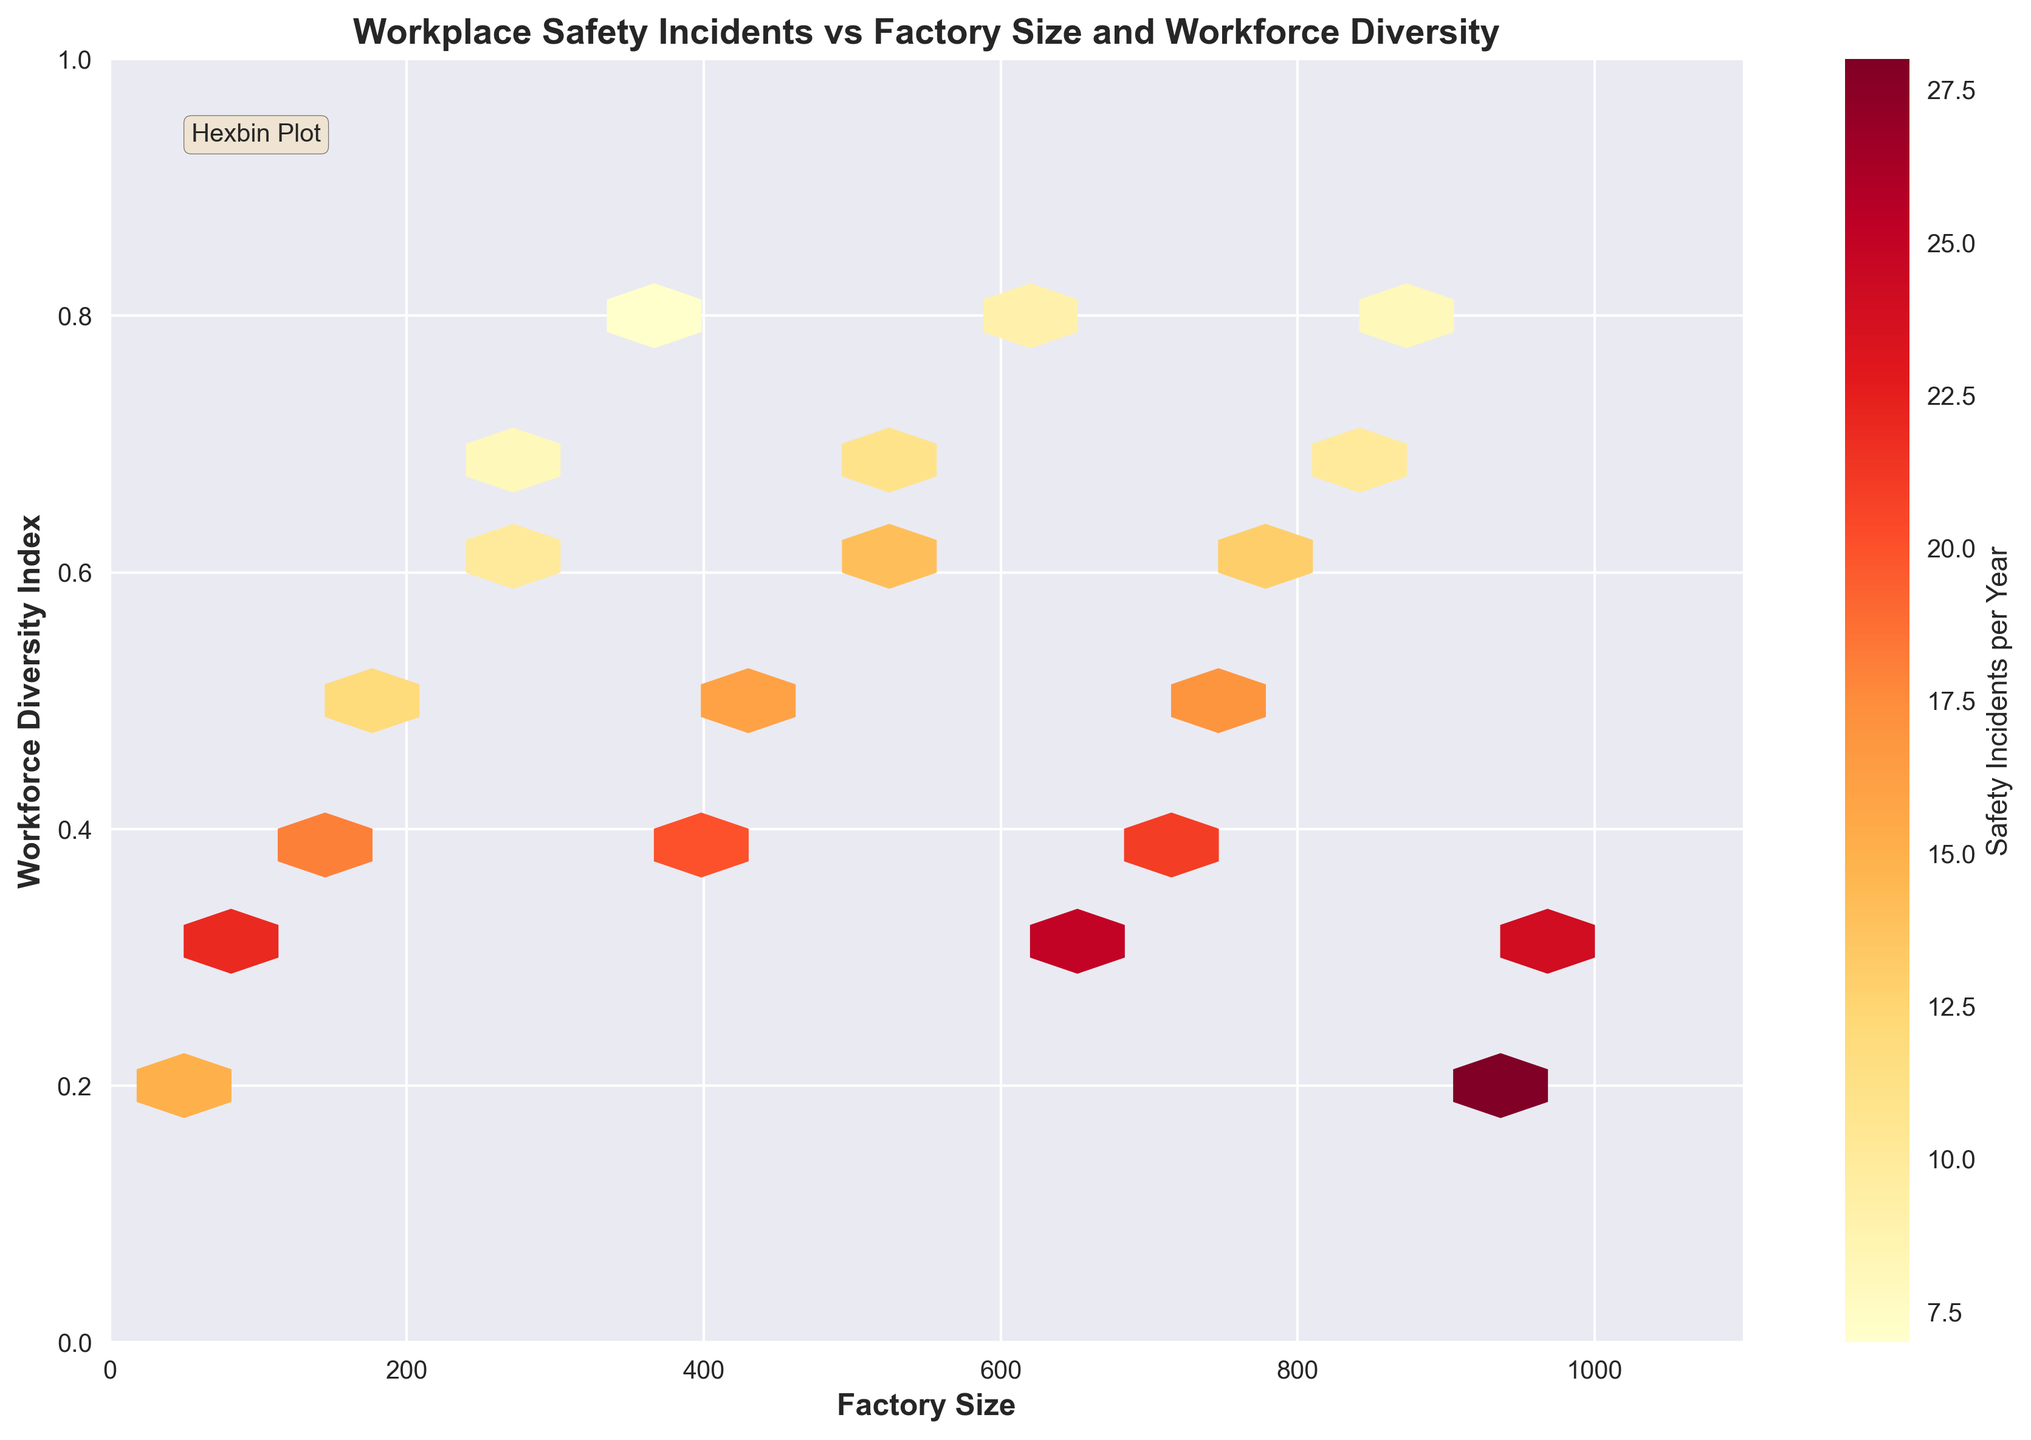What's the title of the plot? The title of the plot is displayed prominently at the top of the figure and reads "Workplace Safety Incidents vs Factory Size and Workforce Diversity".
Answer: Workplace Safety Incidents vs Factory Size and Workforce Diversity What do the colors in the hexagons represent? The colors in the hexagons indicate the number of safety incidents per year. This is shown by the color bar on the right side of the figure.
Answer: The number of safety incidents per year What is the range of the Workforce Diversity Index in the plot? The range of the Workforce Diversity Index is shown on the y-axis, which spans from 0 to 1.
Answer: 0 to 1 Which factory size has the highest frequency of safety incidents? By observing the color intensity of the hexagons, the factory size around 950 has the darkest color on the color bar, indicating the highest frequency of safety incidents.
Answer: Around 950 Is there a noticeable trend between factory size and workforce diversity in relation to safety incidents? There seems to be a trend where factories with smaller sizes and lower workforce diversity tend to have higher safety incidents. This can be inferred from the clustering of darker hexagons in the lower left section of the plot.
Answer: Smaller sizes and lower workforce diversity tend to have higher safety incidents At what factory size and workforce diversity index do we see a notable decrease in safety incidents? By observing the hexagons with lighter colors, a notable decrease in safety incidents can be seen around factory sizes 300-350 and workforce diversity index 0.7-0.8.
Answer: Around factory sizes 300-350 and workforce diversity index 0.7-0.8 Do larger factories (size greater than 700) tend to have fewer safety incidents? Observing the color of hexagons in the plot, larger factories (greater than 700) mostly have lighter-colored hexagons, indicating fewer safety incidents.
Answer: Yes What axes represent Factory Size and Workforce Diversity Index respectively? The horizontal (x) axis represents Factory Size, and the vertical (y) axis represents Workforce Diversity Index, as labeled on the plot.
Answer: x-axis: Factory Size, y-axis: Workforce Diversity Index How does the safety incident frequency vary with increasing workforce diversity for a factory size of 500? As workforce diversity increases around a factory size of 500, the color of the hexagons becomes lighter, indicating a decrease in the number of safety incidents.
Answer: Decreases 